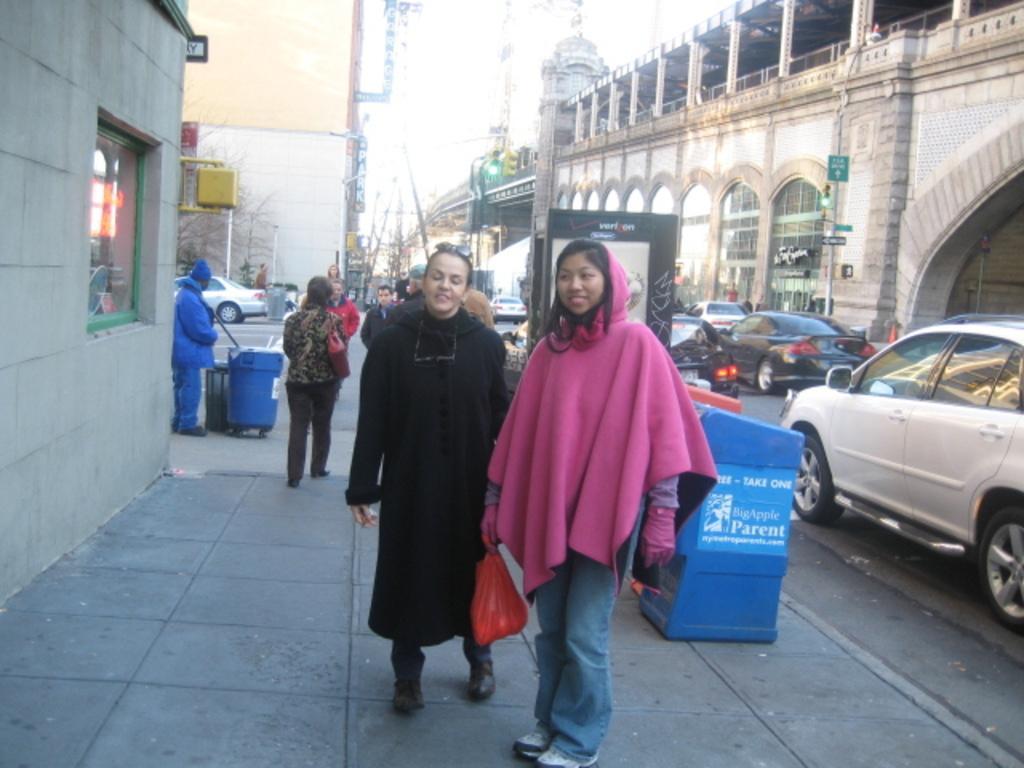Please provide a concise description of this image. In this image I can see the group of people with different color dresses. To the right I can see the dustbins, boards and few vehicles on the road. To the left I can see the window to the wall. In the background I can see few more vehicles, boards, buildings and the sky. 